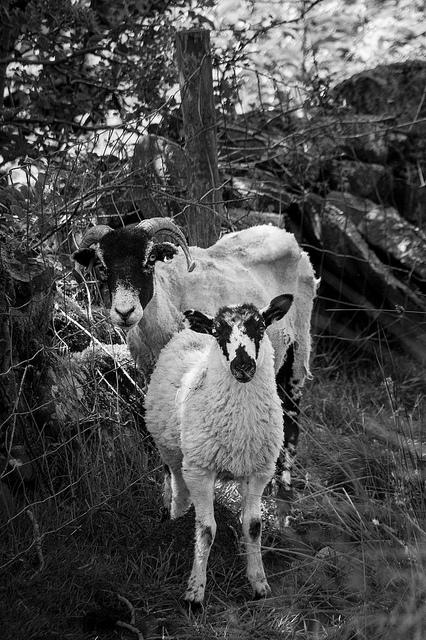What does the far back animal have on his head?
Keep it brief. Horns. Are the sheep and the goats getting along together?
Concise answer only. Yes. What animal is in the picture?
Keep it brief. Goat. Is there a water body nearby?
Give a very brief answer. No. How many sheep have black faces?
Be succinct. 2. Does this animal have feathers?
Keep it brief. No. Do these animals eat fish?
Keep it brief. No. Do the sheep have long hair?
Answer briefly. No. How many sheep in this photo have mostly white faces with a bit of black markings?
Keep it brief. 1. What kind of animal is this?
Write a very short answer. Sheep. 